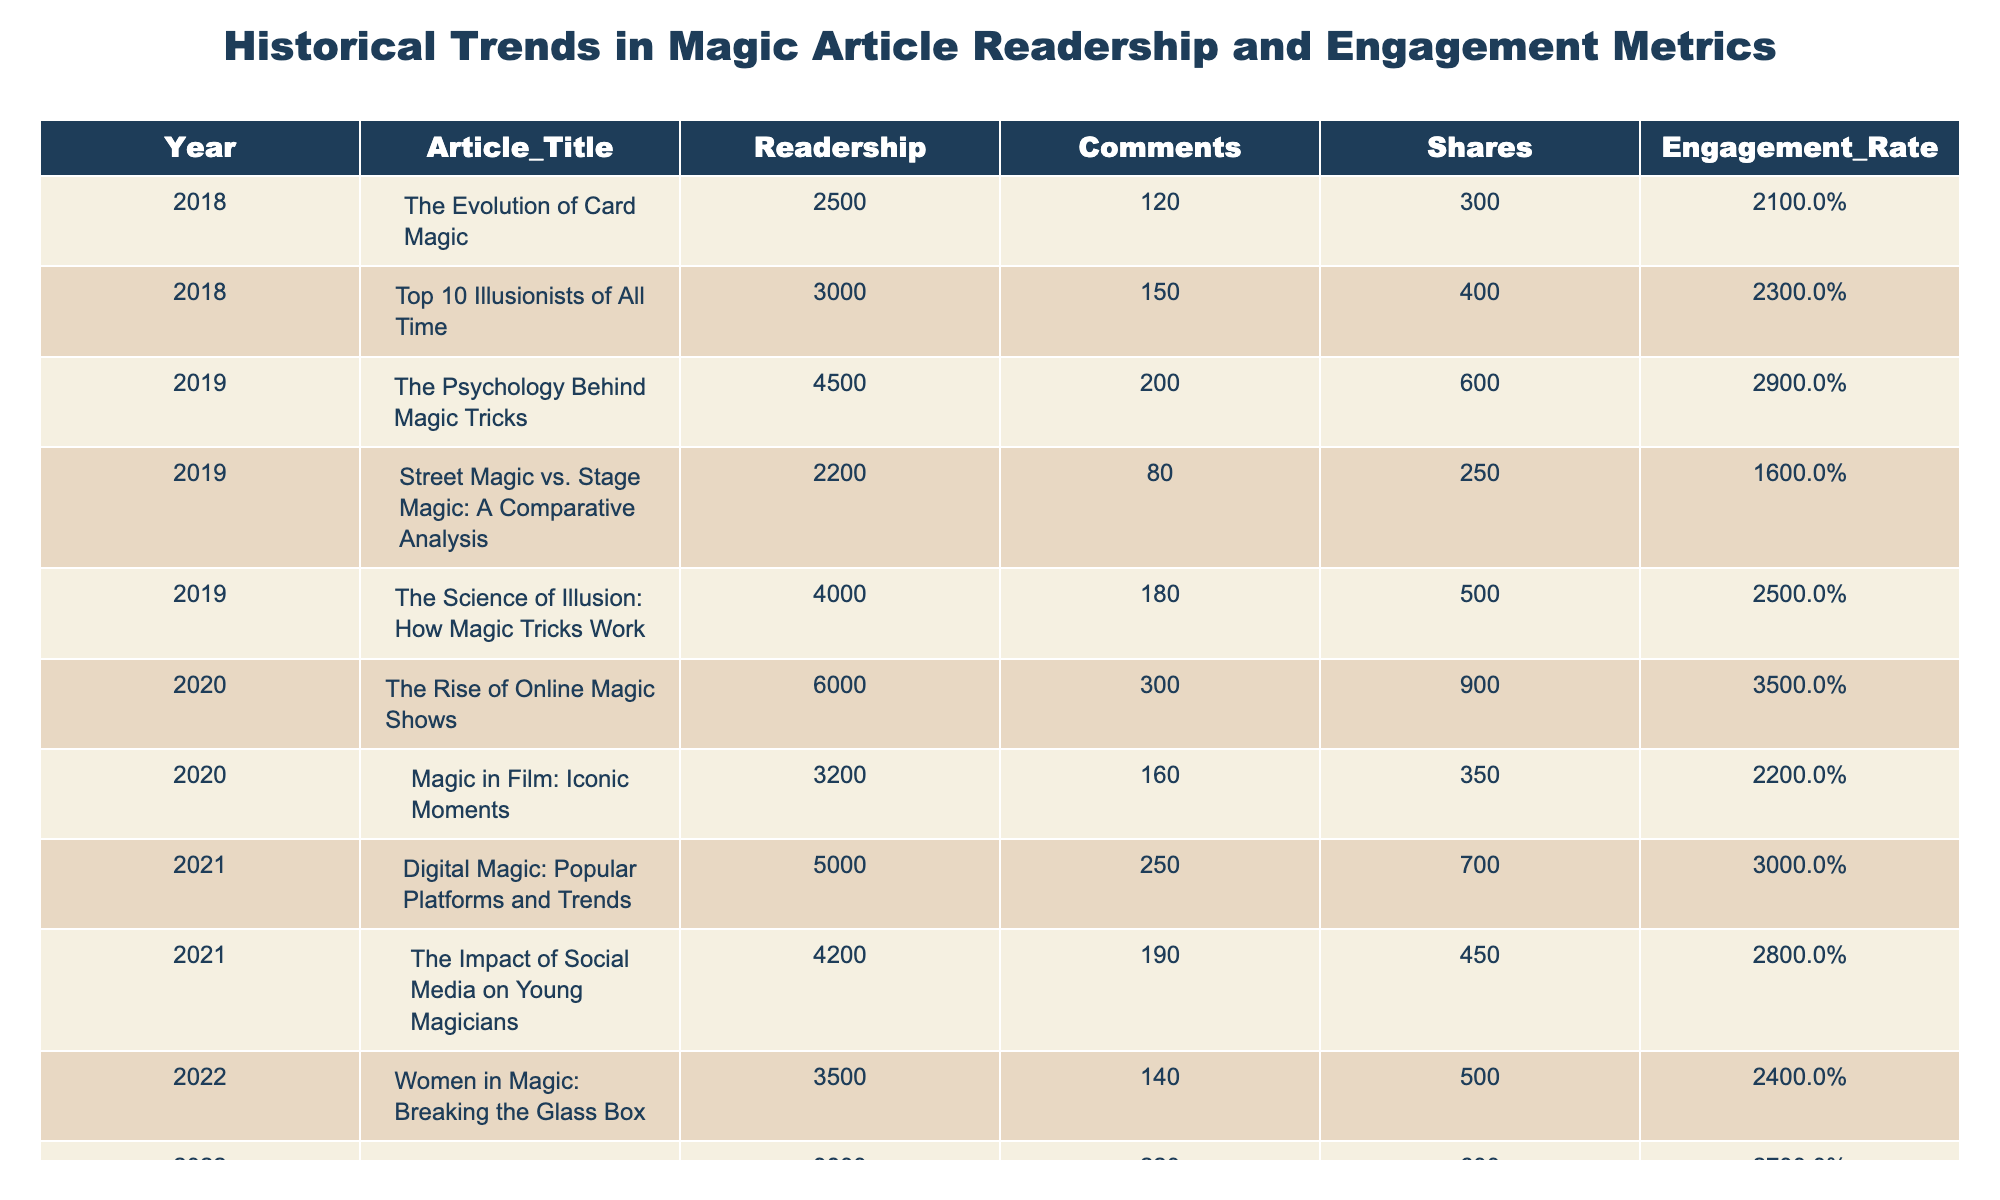What was the readership for the article "The Science of Illusion: How Magic Tricks Work"? The table lists the readership for each article. Looking for the entry corresponding to "The Science of Illusion: How Magic Tricks Work" in the Year 2019, we see that it is 4000.
Answer: 4000 Which article had the highest engagement rate? By reviewing the engagement rates in the table, we find that "The Future of Magic: Trends to Watch" in 2023 has the highest engagement rate at 40%.
Answer: 40% What is the total readership of all articles in 2022? We sum the readership values for all articles in 2022: 3500 + 3800 = 7300.
Answer: 7300 Did any article published in 2018 have more shares than the article "Top 10 Illusionists of All Time"? In the table, "Top 10 Illusionists of All Time" has 400 shares. Looking at the other articles from 2018, "The Evolution of Card Magic" has only 300 shares. Therefore, no articles from 2018 had more shares.
Answer: No What was the difference in readership between the article with the highest readership in 2020 and the lowest in 2019? The highest readership in 2020 is 6000 (for "The Rise of Online Magic Shows") and the lowest in 2019 is 2200 (for "Street Magic vs. Stage Magic: A Comparative Analysis"). The difference is 6000 - 2200 = 3800.
Answer: 3800 What was the average engagement rate for articles published in 2021? The engagement rates for 2021 are 30% and 28%. The average is (30 + 28) / 2 = 29%.
Answer: 29% Which year saw the largest increase in readership compared to the previous year? We look at the total readership for each year: 2018 (5500), 2019 (12400), 2020 (9200), 2021 (9200), 2022 (7300), and 2023 (22000). The largest jump occurs between 2022 and 2023: 22000 - 7300 = 14700, which is greater than any other year's changes.
Answer: 2023 How many articles had an engagement rate of 30% or higher? Checking the engagement rates, we find three articles with rates of 30% or greater in 2020 and 2023, respectively: "The Rise of Online Magic Shows," "The Future of Magic: Trends to Watch," and "Magic and Mentalism: A Deeper Dive." Therefore, there are 5 articles.
Answer: 5 Which article published in 2021 had the most shares? For 2021, we compare the shares: "Digital Magic: Popular Platforms and Trends" has 700 shares and "The Impact of Social Media on Young Magicians" has 450 shares. The former has more shares.
Answer: "Digital Magic: Popular Platforms and Trends" Is there a trend observed in the engagement rates from 2018 to 2023? To check for trend, we look at the engagement rates from 2018 (21%) to 2023 (40%). The rates generally increased each year, indicating a positive trend in engagement over these years.
Answer: Yes 